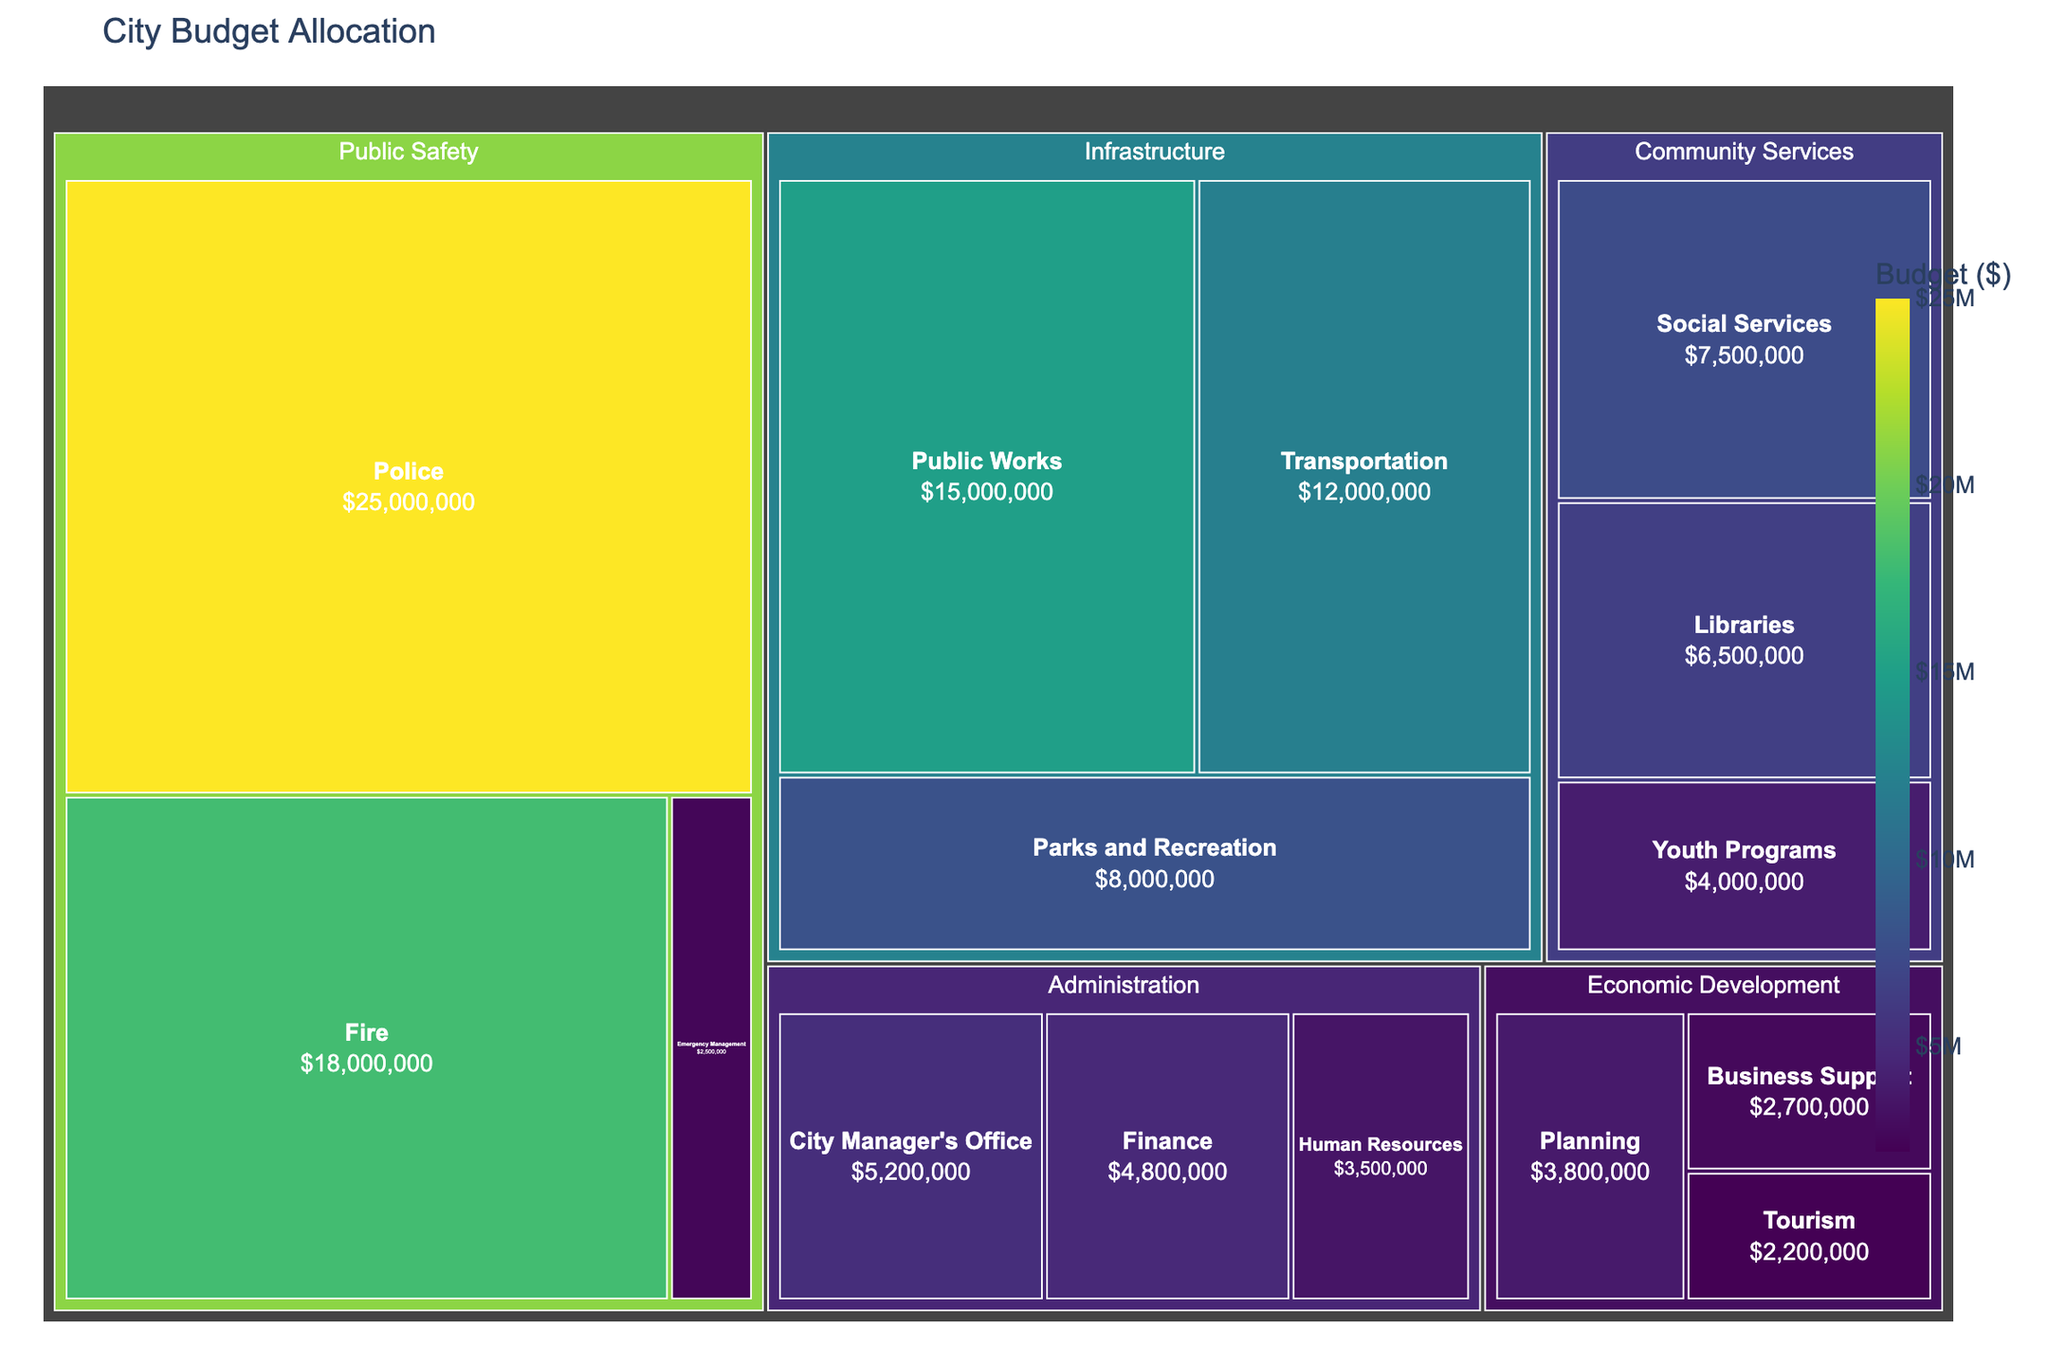What is the total budget allocated to the Administration department? Sum the budgets of City Manager's Office, Finance, and Human Resources within the Administration department. (5,200,000 + 4,800,000 + 3,500,000)
Answer: $13,500,000 What category within Public Safety has the largest budget? Compare the budgets for Police, Fire, and Emergency Management within Public Safety. The Police budget is the largest.
Answer: Police How does the budget for Transportation within Infrastructure compare to the budget for Public Works? The budget for Transportation is $12,000,000 and for Public Works is $15,000,000. Transportation is less than Public Works.
Answer: Transportation has a smaller budget What is the sum of budgets for all categories in Community Services? Add the budgets of Libraries, Social Services, and Youth Programs within Community Services (6,500,000 + 7,500,000 + 4,000,000)
Answer: $18,000,000 Which department has the smallest total budget allocation? Compare the total budgets of all departments. Economic Development has the smallest total budget.
Answer: Economic Development Which single category has the highest budget allocation across all departments? Compare budgets of all categories across departments. The Police within Public Safety has the highest budget allocation.
Answer: Police In the chart, which two categories have a combined budget closest to $10,000,000? From the chart compare combinations of categories. Libraries and Social Services within Community Services have a combined budget close to $10,000,000 (6,500,000 + 7,500,000 = 14,000,000; a closer combination is Finance (Administration) and Youth Programs (3,500,000 + 4,000,000).
Answer: Finance and Youth Programs 